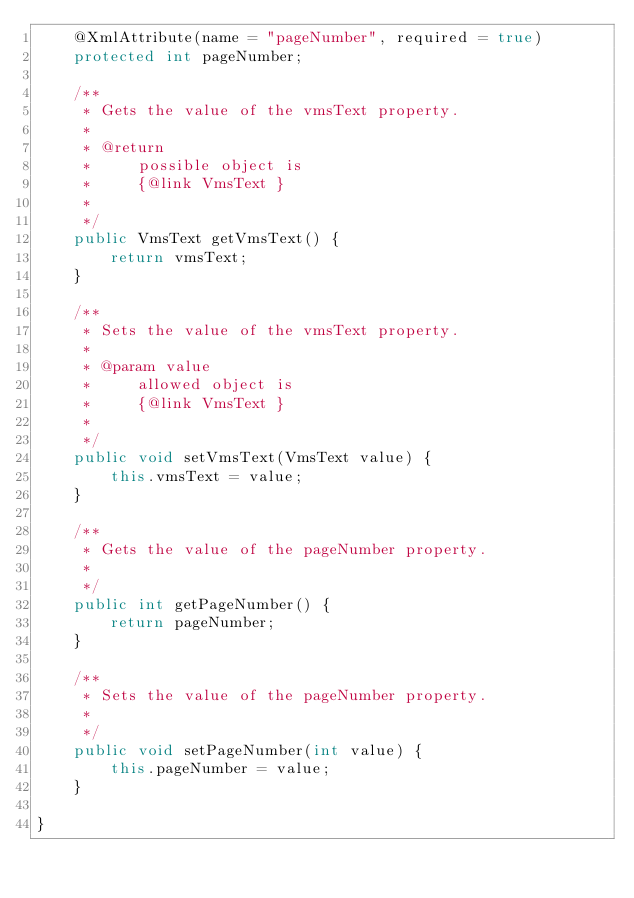<code> <loc_0><loc_0><loc_500><loc_500><_Java_>    @XmlAttribute(name = "pageNumber", required = true)
    protected int pageNumber;

    /**
     * Gets the value of the vmsText property.
     * 
     * @return
     *     possible object is
     *     {@link VmsText }
     *     
     */
    public VmsText getVmsText() {
        return vmsText;
    }

    /**
     * Sets the value of the vmsText property.
     * 
     * @param value
     *     allowed object is
     *     {@link VmsText }
     *     
     */
    public void setVmsText(VmsText value) {
        this.vmsText = value;
    }

    /**
     * Gets the value of the pageNumber property.
     * 
     */
    public int getPageNumber() {
        return pageNumber;
    }

    /**
     * Sets the value of the pageNumber property.
     * 
     */
    public void setPageNumber(int value) {
        this.pageNumber = value;
    }

}
</code> 